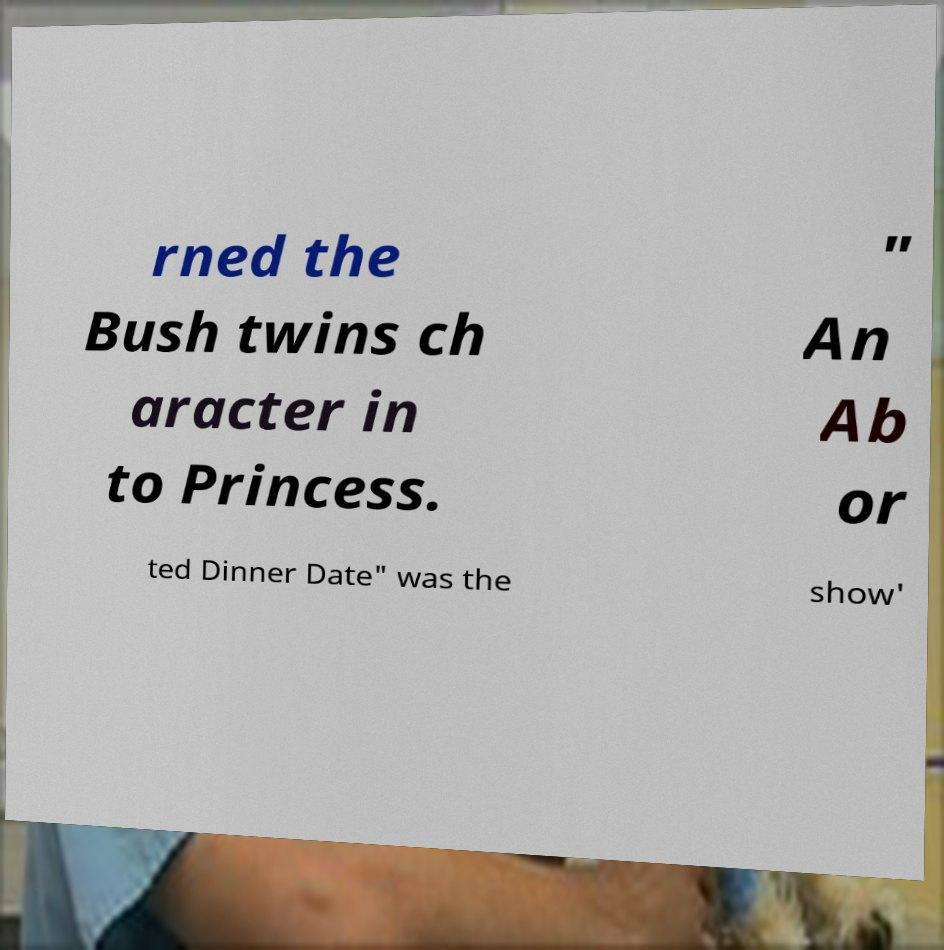Can you accurately transcribe the text from the provided image for me? rned the Bush twins ch aracter in to Princess. " An Ab or ted Dinner Date" was the show' 